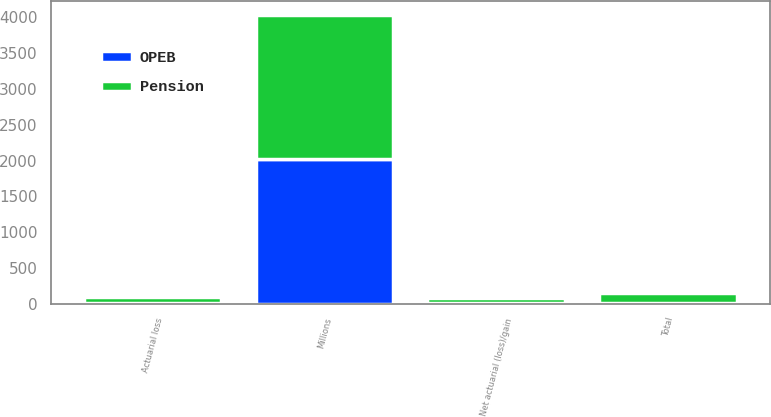Convert chart to OTSL. <chart><loc_0><loc_0><loc_500><loc_500><stacked_bar_chart><ecel><fcel>Millions<fcel>Net actuarial (loss)/gain<fcel>Actuarial loss<fcel>Total<nl><fcel>Pension<fcel>2017<fcel>67<fcel>81<fcel>148<nl><fcel>OPEB<fcel>2017<fcel>6<fcel>9<fcel>4<nl></chart> 